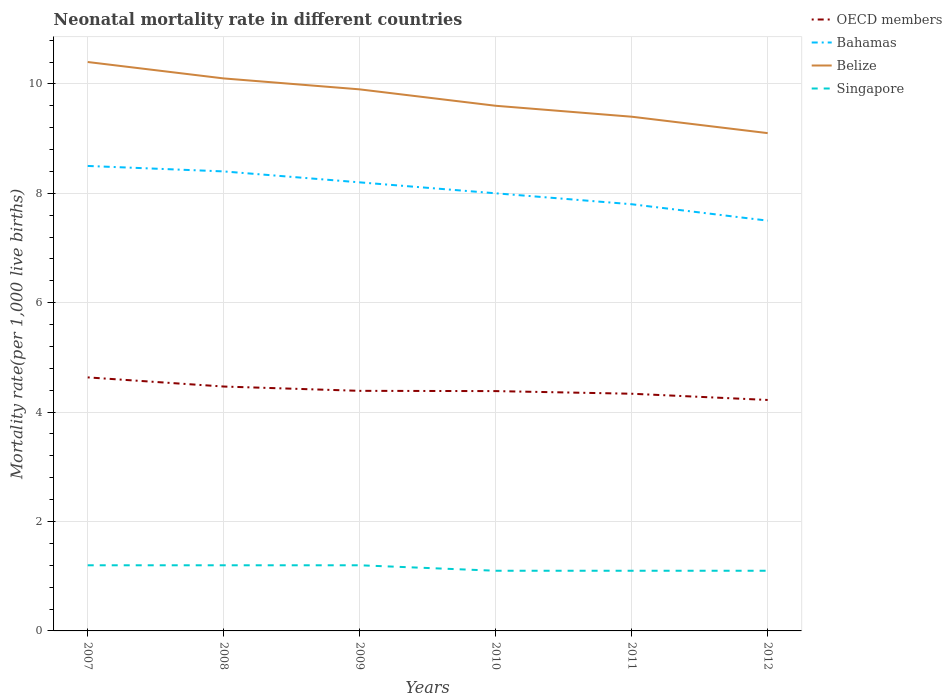How many different coloured lines are there?
Keep it short and to the point. 4. Does the line corresponding to Singapore intersect with the line corresponding to Bahamas?
Your answer should be very brief. No. In which year was the neonatal mortality rate in Singapore maximum?
Provide a succinct answer. 2010. What is the total neonatal mortality rate in Belize in the graph?
Your answer should be very brief. 1.3. What is the difference between the highest and the second highest neonatal mortality rate in Singapore?
Your response must be concise. 0.1. What is the difference between the highest and the lowest neonatal mortality rate in OECD members?
Give a very brief answer. 2. What is the difference between two consecutive major ticks on the Y-axis?
Provide a succinct answer. 2. Are the values on the major ticks of Y-axis written in scientific E-notation?
Provide a succinct answer. No. Does the graph contain grids?
Provide a succinct answer. Yes. How many legend labels are there?
Your answer should be compact. 4. What is the title of the graph?
Offer a very short reply. Neonatal mortality rate in different countries. What is the label or title of the Y-axis?
Ensure brevity in your answer.  Mortality rate(per 1,0 live births). What is the Mortality rate(per 1,000 live births) in OECD members in 2007?
Your answer should be very brief. 4.63. What is the Mortality rate(per 1,000 live births) of Belize in 2007?
Provide a succinct answer. 10.4. What is the Mortality rate(per 1,000 live births) in Singapore in 2007?
Keep it short and to the point. 1.2. What is the Mortality rate(per 1,000 live births) in OECD members in 2008?
Offer a very short reply. 4.47. What is the Mortality rate(per 1,000 live births) of Bahamas in 2008?
Your answer should be very brief. 8.4. What is the Mortality rate(per 1,000 live births) of Belize in 2008?
Your response must be concise. 10.1. What is the Mortality rate(per 1,000 live births) in Singapore in 2008?
Make the answer very short. 1.2. What is the Mortality rate(per 1,000 live births) of OECD members in 2009?
Your answer should be compact. 4.39. What is the Mortality rate(per 1,000 live births) of Bahamas in 2009?
Keep it short and to the point. 8.2. What is the Mortality rate(per 1,000 live births) in Singapore in 2009?
Offer a terse response. 1.2. What is the Mortality rate(per 1,000 live births) of OECD members in 2010?
Provide a succinct answer. 4.38. What is the Mortality rate(per 1,000 live births) in Belize in 2010?
Provide a succinct answer. 9.6. What is the Mortality rate(per 1,000 live births) of Singapore in 2010?
Provide a short and direct response. 1.1. What is the Mortality rate(per 1,000 live births) of OECD members in 2011?
Ensure brevity in your answer.  4.34. What is the Mortality rate(per 1,000 live births) of OECD members in 2012?
Keep it short and to the point. 4.22. What is the Mortality rate(per 1,000 live births) of Bahamas in 2012?
Make the answer very short. 7.5. What is the Mortality rate(per 1,000 live births) in Singapore in 2012?
Give a very brief answer. 1.1. Across all years, what is the maximum Mortality rate(per 1,000 live births) of OECD members?
Your response must be concise. 4.63. Across all years, what is the maximum Mortality rate(per 1,000 live births) of Belize?
Ensure brevity in your answer.  10.4. Across all years, what is the minimum Mortality rate(per 1,000 live births) of OECD members?
Give a very brief answer. 4.22. Across all years, what is the minimum Mortality rate(per 1,000 live births) of Singapore?
Give a very brief answer. 1.1. What is the total Mortality rate(per 1,000 live births) in OECD members in the graph?
Keep it short and to the point. 26.43. What is the total Mortality rate(per 1,000 live births) in Bahamas in the graph?
Provide a short and direct response. 48.4. What is the total Mortality rate(per 1,000 live births) in Belize in the graph?
Make the answer very short. 58.5. What is the difference between the Mortality rate(per 1,000 live births) in OECD members in 2007 and that in 2008?
Keep it short and to the point. 0.17. What is the difference between the Mortality rate(per 1,000 live births) in Bahamas in 2007 and that in 2008?
Your response must be concise. 0.1. What is the difference between the Mortality rate(per 1,000 live births) of OECD members in 2007 and that in 2009?
Offer a very short reply. 0.25. What is the difference between the Mortality rate(per 1,000 live births) of Bahamas in 2007 and that in 2009?
Keep it short and to the point. 0.3. What is the difference between the Mortality rate(per 1,000 live births) of Singapore in 2007 and that in 2009?
Offer a terse response. 0. What is the difference between the Mortality rate(per 1,000 live births) in OECD members in 2007 and that in 2010?
Provide a short and direct response. 0.25. What is the difference between the Mortality rate(per 1,000 live births) in Belize in 2007 and that in 2010?
Provide a succinct answer. 0.8. What is the difference between the Mortality rate(per 1,000 live births) in Singapore in 2007 and that in 2010?
Offer a very short reply. 0.1. What is the difference between the Mortality rate(per 1,000 live births) of OECD members in 2007 and that in 2011?
Your answer should be compact. 0.3. What is the difference between the Mortality rate(per 1,000 live births) in OECD members in 2007 and that in 2012?
Ensure brevity in your answer.  0.41. What is the difference between the Mortality rate(per 1,000 live births) of Bahamas in 2007 and that in 2012?
Offer a terse response. 1. What is the difference between the Mortality rate(per 1,000 live births) of OECD members in 2008 and that in 2009?
Give a very brief answer. 0.08. What is the difference between the Mortality rate(per 1,000 live births) in Belize in 2008 and that in 2009?
Offer a very short reply. 0.2. What is the difference between the Mortality rate(per 1,000 live births) of Singapore in 2008 and that in 2009?
Keep it short and to the point. 0. What is the difference between the Mortality rate(per 1,000 live births) in OECD members in 2008 and that in 2010?
Offer a very short reply. 0.08. What is the difference between the Mortality rate(per 1,000 live births) of Belize in 2008 and that in 2010?
Your answer should be very brief. 0.5. What is the difference between the Mortality rate(per 1,000 live births) of Singapore in 2008 and that in 2010?
Provide a succinct answer. 0.1. What is the difference between the Mortality rate(per 1,000 live births) in OECD members in 2008 and that in 2011?
Provide a succinct answer. 0.13. What is the difference between the Mortality rate(per 1,000 live births) of Singapore in 2008 and that in 2011?
Offer a very short reply. 0.1. What is the difference between the Mortality rate(per 1,000 live births) in OECD members in 2008 and that in 2012?
Your answer should be very brief. 0.25. What is the difference between the Mortality rate(per 1,000 live births) of OECD members in 2009 and that in 2010?
Make the answer very short. 0. What is the difference between the Mortality rate(per 1,000 live births) of OECD members in 2009 and that in 2011?
Offer a terse response. 0.05. What is the difference between the Mortality rate(per 1,000 live births) of Bahamas in 2009 and that in 2011?
Offer a terse response. 0.4. What is the difference between the Mortality rate(per 1,000 live births) of Belize in 2009 and that in 2011?
Your answer should be very brief. 0.5. What is the difference between the Mortality rate(per 1,000 live births) in OECD members in 2009 and that in 2012?
Make the answer very short. 0.17. What is the difference between the Mortality rate(per 1,000 live births) in Singapore in 2009 and that in 2012?
Provide a succinct answer. 0.1. What is the difference between the Mortality rate(per 1,000 live births) in OECD members in 2010 and that in 2011?
Ensure brevity in your answer.  0.05. What is the difference between the Mortality rate(per 1,000 live births) in Bahamas in 2010 and that in 2011?
Your answer should be compact. 0.2. What is the difference between the Mortality rate(per 1,000 live births) in Belize in 2010 and that in 2011?
Provide a succinct answer. 0.2. What is the difference between the Mortality rate(per 1,000 live births) of OECD members in 2010 and that in 2012?
Give a very brief answer. 0.16. What is the difference between the Mortality rate(per 1,000 live births) of OECD members in 2011 and that in 2012?
Make the answer very short. 0.11. What is the difference between the Mortality rate(per 1,000 live births) in Belize in 2011 and that in 2012?
Your response must be concise. 0.3. What is the difference between the Mortality rate(per 1,000 live births) in OECD members in 2007 and the Mortality rate(per 1,000 live births) in Bahamas in 2008?
Make the answer very short. -3.77. What is the difference between the Mortality rate(per 1,000 live births) of OECD members in 2007 and the Mortality rate(per 1,000 live births) of Belize in 2008?
Give a very brief answer. -5.47. What is the difference between the Mortality rate(per 1,000 live births) in OECD members in 2007 and the Mortality rate(per 1,000 live births) in Singapore in 2008?
Provide a succinct answer. 3.43. What is the difference between the Mortality rate(per 1,000 live births) of Belize in 2007 and the Mortality rate(per 1,000 live births) of Singapore in 2008?
Your answer should be compact. 9.2. What is the difference between the Mortality rate(per 1,000 live births) of OECD members in 2007 and the Mortality rate(per 1,000 live births) of Bahamas in 2009?
Provide a short and direct response. -3.57. What is the difference between the Mortality rate(per 1,000 live births) in OECD members in 2007 and the Mortality rate(per 1,000 live births) in Belize in 2009?
Give a very brief answer. -5.27. What is the difference between the Mortality rate(per 1,000 live births) in OECD members in 2007 and the Mortality rate(per 1,000 live births) in Singapore in 2009?
Give a very brief answer. 3.43. What is the difference between the Mortality rate(per 1,000 live births) of OECD members in 2007 and the Mortality rate(per 1,000 live births) of Bahamas in 2010?
Your response must be concise. -3.37. What is the difference between the Mortality rate(per 1,000 live births) in OECD members in 2007 and the Mortality rate(per 1,000 live births) in Belize in 2010?
Your answer should be very brief. -4.97. What is the difference between the Mortality rate(per 1,000 live births) of OECD members in 2007 and the Mortality rate(per 1,000 live births) of Singapore in 2010?
Ensure brevity in your answer.  3.53. What is the difference between the Mortality rate(per 1,000 live births) in Bahamas in 2007 and the Mortality rate(per 1,000 live births) in Belize in 2010?
Make the answer very short. -1.1. What is the difference between the Mortality rate(per 1,000 live births) in Belize in 2007 and the Mortality rate(per 1,000 live births) in Singapore in 2010?
Offer a very short reply. 9.3. What is the difference between the Mortality rate(per 1,000 live births) of OECD members in 2007 and the Mortality rate(per 1,000 live births) of Bahamas in 2011?
Your answer should be very brief. -3.17. What is the difference between the Mortality rate(per 1,000 live births) of OECD members in 2007 and the Mortality rate(per 1,000 live births) of Belize in 2011?
Give a very brief answer. -4.77. What is the difference between the Mortality rate(per 1,000 live births) in OECD members in 2007 and the Mortality rate(per 1,000 live births) in Singapore in 2011?
Ensure brevity in your answer.  3.53. What is the difference between the Mortality rate(per 1,000 live births) of OECD members in 2007 and the Mortality rate(per 1,000 live births) of Bahamas in 2012?
Give a very brief answer. -2.87. What is the difference between the Mortality rate(per 1,000 live births) in OECD members in 2007 and the Mortality rate(per 1,000 live births) in Belize in 2012?
Offer a terse response. -4.47. What is the difference between the Mortality rate(per 1,000 live births) of OECD members in 2007 and the Mortality rate(per 1,000 live births) of Singapore in 2012?
Ensure brevity in your answer.  3.53. What is the difference between the Mortality rate(per 1,000 live births) of Bahamas in 2007 and the Mortality rate(per 1,000 live births) of Singapore in 2012?
Provide a succinct answer. 7.4. What is the difference between the Mortality rate(per 1,000 live births) in OECD members in 2008 and the Mortality rate(per 1,000 live births) in Bahamas in 2009?
Offer a very short reply. -3.73. What is the difference between the Mortality rate(per 1,000 live births) of OECD members in 2008 and the Mortality rate(per 1,000 live births) of Belize in 2009?
Make the answer very short. -5.43. What is the difference between the Mortality rate(per 1,000 live births) in OECD members in 2008 and the Mortality rate(per 1,000 live births) in Singapore in 2009?
Keep it short and to the point. 3.27. What is the difference between the Mortality rate(per 1,000 live births) in Bahamas in 2008 and the Mortality rate(per 1,000 live births) in Singapore in 2009?
Provide a succinct answer. 7.2. What is the difference between the Mortality rate(per 1,000 live births) of OECD members in 2008 and the Mortality rate(per 1,000 live births) of Bahamas in 2010?
Your response must be concise. -3.53. What is the difference between the Mortality rate(per 1,000 live births) in OECD members in 2008 and the Mortality rate(per 1,000 live births) in Belize in 2010?
Your answer should be very brief. -5.13. What is the difference between the Mortality rate(per 1,000 live births) of OECD members in 2008 and the Mortality rate(per 1,000 live births) of Singapore in 2010?
Give a very brief answer. 3.37. What is the difference between the Mortality rate(per 1,000 live births) of OECD members in 2008 and the Mortality rate(per 1,000 live births) of Bahamas in 2011?
Give a very brief answer. -3.33. What is the difference between the Mortality rate(per 1,000 live births) in OECD members in 2008 and the Mortality rate(per 1,000 live births) in Belize in 2011?
Offer a terse response. -4.93. What is the difference between the Mortality rate(per 1,000 live births) of OECD members in 2008 and the Mortality rate(per 1,000 live births) of Singapore in 2011?
Offer a very short reply. 3.37. What is the difference between the Mortality rate(per 1,000 live births) in Bahamas in 2008 and the Mortality rate(per 1,000 live births) in Belize in 2011?
Keep it short and to the point. -1. What is the difference between the Mortality rate(per 1,000 live births) of Bahamas in 2008 and the Mortality rate(per 1,000 live births) of Singapore in 2011?
Your answer should be very brief. 7.3. What is the difference between the Mortality rate(per 1,000 live births) in Belize in 2008 and the Mortality rate(per 1,000 live births) in Singapore in 2011?
Give a very brief answer. 9. What is the difference between the Mortality rate(per 1,000 live births) in OECD members in 2008 and the Mortality rate(per 1,000 live births) in Bahamas in 2012?
Give a very brief answer. -3.03. What is the difference between the Mortality rate(per 1,000 live births) in OECD members in 2008 and the Mortality rate(per 1,000 live births) in Belize in 2012?
Make the answer very short. -4.63. What is the difference between the Mortality rate(per 1,000 live births) in OECD members in 2008 and the Mortality rate(per 1,000 live births) in Singapore in 2012?
Give a very brief answer. 3.37. What is the difference between the Mortality rate(per 1,000 live births) in Bahamas in 2008 and the Mortality rate(per 1,000 live births) in Belize in 2012?
Make the answer very short. -0.7. What is the difference between the Mortality rate(per 1,000 live births) in Bahamas in 2008 and the Mortality rate(per 1,000 live births) in Singapore in 2012?
Your answer should be very brief. 7.3. What is the difference between the Mortality rate(per 1,000 live births) of Belize in 2008 and the Mortality rate(per 1,000 live births) of Singapore in 2012?
Ensure brevity in your answer.  9. What is the difference between the Mortality rate(per 1,000 live births) of OECD members in 2009 and the Mortality rate(per 1,000 live births) of Bahamas in 2010?
Ensure brevity in your answer.  -3.61. What is the difference between the Mortality rate(per 1,000 live births) of OECD members in 2009 and the Mortality rate(per 1,000 live births) of Belize in 2010?
Provide a short and direct response. -5.21. What is the difference between the Mortality rate(per 1,000 live births) in OECD members in 2009 and the Mortality rate(per 1,000 live births) in Singapore in 2010?
Keep it short and to the point. 3.29. What is the difference between the Mortality rate(per 1,000 live births) of Bahamas in 2009 and the Mortality rate(per 1,000 live births) of Belize in 2010?
Provide a short and direct response. -1.4. What is the difference between the Mortality rate(per 1,000 live births) in OECD members in 2009 and the Mortality rate(per 1,000 live births) in Bahamas in 2011?
Offer a very short reply. -3.41. What is the difference between the Mortality rate(per 1,000 live births) in OECD members in 2009 and the Mortality rate(per 1,000 live births) in Belize in 2011?
Your answer should be compact. -5.01. What is the difference between the Mortality rate(per 1,000 live births) in OECD members in 2009 and the Mortality rate(per 1,000 live births) in Singapore in 2011?
Offer a terse response. 3.29. What is the difference between the Mortality rate(per 1,000 live births) of Bahamas in 2009 and the Mortality rate(per 1,000 live births) of Belize in 2011?
Offer a terse response. -1.2. What is the difference between the Mortality rate(per 1,000 live births) in Bahamas in 2009 and the Mortality rate(per 1,000 live births) in Singapore in 2011?
Your answer should be very brief. 7.1. What is the difference between the Mortality rate(per 1,000 live births) of OECD members in 2009 and the Mortality rate(per 1,000 live births) of Bahamas in 2012?
Give a very brief answer. -3.11. What is the difference between the Mortality rate(per 1,000 live births) of OECD members in 2009 and the Mortality rate(per 1,000 live births) of Belize in 2012?
Offer a very short reply. -4.71. What is the difference between the Mortality rate(per 1,000 live births) of OECD members in 2009 and the Mortality rate(per 1,000 live births) of Singapore in 2012?
Offer a terse response. 3.29. What is the difference between the Mortality rate(per 1,000 live births) in Bahamas in 2009 and the Mortality rate(per 1,000 live births) in Belize in 2012?
Provide a succinct answer. -0.9. What is the difference between the Mortality rate(per 1,000 live births) of Belize in 2009 and the Mortality rate(per 1,000 live births) of Singapore in 2012?
Keep it short and to the point. 8.8. What is the difference between the Mortality rate(per 1,000 live births) of OECD members in 2010 and the Mortality rate(per 1,000 live births) of Bahamas in 2011?
Provide a succinct answer. -3.42. What is the difference between the Mortality rate(per 1,000 live births) of OECD members in 2010 and the Mortality rate(per 1,000 live births) of Belize in 2011?
Your response must be concise. -5.02. What is the difference between the Mortality rate(per 1,000 live births) of OECD members in 2010 and the Mortality rate(per 1,000 live births) of Singapore in 2011?
Your answer should be compact. 3.28. What is the difference between the Mortality rate(per 1,000 live births) in Bahamas in 2010 and the Mortality rate(per 1,000 live births) in Singapore in 2011?
Your answer should be very brief. 6.9. What is the difference between the Mortality rate(per 1,000 live births) of Belize in 2010 and the Mortality rate(per 1,000 live births) of Singapore in 2011?
Your answer should be compact. 8.5. What is the difference between the Mortality rate(per 1,000 live births) of OECD members in 2010 and the Mortality rate(per 1,000 live births) of Bahamas in 2012?
Provide a short and direct response. -3.12. What is the difference between the Mortality rate(per 1,000 live births) in OECD members in 2010 and the Mortality rate(per 1,000 live births) in Belize in 2012?
Your answer should be very brief. -4.72. What is the difference between the Mortality rate(per 1,000 live births) of OECD members in 2010 and the Mortality rate(per 1,000 live births) of Singapore in 2012?
Offer a terse response. 3.28. What is the difference between the Mortality rate(per 1,000 live births) of Bahamas in 2010 and the Mortality rate(per 1,000 live births) of Singapore in 2012?
Offer a very short reply. 6.9. What is the difference between the Mortality rate(per 1,000 live births) in OECD members in 2011 and the Mortality rate(per 1,000 live births) in Bahamas in 2012?
Keep it short and to the point. -3.16. What is the difference between the Mortality rate(per 1,000 live births) of OECD members in 2011 and the Mortality rate(per 1,000 live births) of Belize in 2012?
Your answer should be compact. -4.76. What is the difference between the Mortality rate(per 1,000 live births) in OECD members in 2011 and the Mortality rate(per 1,000 live births) in Singapore in 2012?
Give a very brief answer. 3.24. What is the difference between the Mortality rate(per 1,000 live births) of Bahamas in 2011 and the Mortality rate(per 1,000 live births) of Belize in 2012?
Offer a terse response. -1.3. What is the average Mortality rate(per 1,000 live births) of OECD members per year?
Give a very brief answer. 4.41. What is the average Mortality rate(per 1,000 live births) in Bahamas per year?
Your response must be concise. 8.07. What is the average Mortality rate(per 1,000 live births) of Belize per year?
Your answer should be very brief. 9.75. What is the average Mortality rate(per 1,000 live births) of Singapore per year?
Your answer should be very brief. 1.15. In the year 2007, what is the difference between the Mortality rate(per 1,000 live births) of OECD members and Mortality rate(per 1,000 live births) of Bahamas?
Your answer should be compact. -3.87. In the year 2007, what is the difference between the Mortality rate(per 1,000 live births) of OECD members and Mortality rate(per 1,000 live births) of Belize?
Your answer should be very brief. -5.77. In the year 2007, what is the difference between the Mortality rate(per 1,000 live births) of OECD members and Mortality rate(per 1,000 live births) of Singapore?
Your response must be concise. 3.43. In the year 2007, what is the difference between the Mortality rate(per 1,000 live births) in Bahamas and Mortality rate(per 1,000 live births) in Belize?
Provide a short and direct response. -1.9. In the year 2007, what is the difference between the Mortality rate(per 1,000 live births) in Bahamas and Mortality rate(per 1,000 live births) in Singapore?
Give a very brief answer. 7.3. In the year 2008, what is the difference between the Mortality rate(per 1,000 live births) of OECD members and Mortality rate(per 1,000 live births) of Bahamas?
Ensure brevity in your answer.  -3.93. In the year 2008, what is the difference between the Mortality rate(per 1,000 live births) of OECD members and Mortality rate(per 1,000 live births) of Belize?
Your answer should be compact. -5.63. In the year 2008, what is the difference between the Mortality rate(per 1,000 live births) of OECD members and Mortality rate(per 1,000 live births) of Singapore?
Your response must be concise. 3.27. In the year 2008, what is the difference between the Mortality rate(per 1,000 live births) in Bahamas and Mortality rate(per 1,000 live births) in Singapore?
Your answer should be compact. 7.2. In the year 2009, what is the difference between the Mortality rate(per 1,000 live births) of OECD members and Mortality rate(per 1,000 live births) of Bahamas?
Provide a succinct answer. -3.81. In the year 2009, what is the difference between the Mortality rate(per 1,000 live births) in OECD members and Mortality rate(per 1,000 live births) in Belize?
Make the answer very short. -5.51. In the year 2009, what is the difference between the Mortality rate(per 1,000 live births) in OECD members and Mortality rate(per 1,000 live births) in Singapore?
Give a very brief answer. 3.19. In the year 2009, what is the difference between the Mortality rate(per 1,000 live births) in Bahamas and Mortality rate(per 1,000 live births) in Singapore?
Make the answer very short. 7. In the year 2009, what is the difference between the Mortality rate(per 1,000 live births) of Belize and Mortality rate(per 1,000 live births) of Singapore?
Your answer should be compact. 8.7. In the year 2010, what is the difference between the Mortality rate(per 1,000 live births) in OECD members and Mortality rate(per 1,000 live births) in Bahamas?
Offer a very short reply. -3.62. In the year 2010, what is the difference between the Mortality rate(per 1,000 live births) in OECD members and Mortality rate(per 1,000 live births) in Belize?
Your answer should be very brief. -5.22. In the year 2010, what is the difference between the Mortality rate(per 1,000 live births) in OECD members and Mortality rate(per 1,000 live births) in Singapore?
Offer a very short reply. 3.28. In the year 2010, what is the difference between the Mortality rate(per 1,000 live births) in Bahamas and Mortality rate(per 1,000 live births) in Belize?
Give a very brief answer. -1.6. In the year 2010, what is the difference between the Mortality rate(per 1,000 live births) of Belize and Mortality rate(per 1,000 live births) of Singapore?
Your answer should be compact. 8.5. In the year 2011, what is the difference between the Mortality rate(per 1,000 live births) of OECD members and Mortality rate(per 1,000 live births) of Bahamas?
Provide a succinct answer. -3.46. In the year 2011, what is the difference between the Mortality rate(per 1,000 live births) of OECD members and Mortality rate(per 1,000 live births) of Belize?
Offer a terse response. -5.06. In the year 2011, what is the difference between the Mortality rate(per 1,000 live births) in OECD members and Mortality rate(per 1,000 live births) in Singapore?
Provide a short and direct response. 3.24. In the year 2011, what is the difference between the Mortality rate(per 1,000 live births) of Bahamas and Mortality rate(per 1,000 live births) of Belize?
Provide a succinct answer. -1.6. In the year 2011, what is the difference between the Mortality rate(per 1,000 live births) in Belize and Mortality rate(per 1,000 live births) in Singapore?
Offer a very short reply. 8.3. In the year 2012, what is the difference between the Mortality rate(per 1,000 live births) in OECD members and Mortality rate(per 1,000 live births) in Bahamas?
Your response must be concise. -3.28. In the year 2012, what is the difference between the Mortality rate(per 1,000 live births) in OECD members and Mortality rate(per 1,000 live births) in Belize?
Your response must be concise. -4.88. In the year 2012, what is the difference between the Mortality rate(per 1,000 live births) of OECD members and Mortality rate(per 1,000 live births) of Singapore?
Your response must be concise. 3.12. In the year 2012, what is the difference between the Mortality rate(per 1,000 live births) in Bahamas and Mortality rate(per 1,000 live births) in Singapore?
Provide a short and direct response. 6.4. What is the ratio of the Mortality rate(per 1,000 live births) of OECD members in 2007 to that in 2008?
Give a very brief answer. 1.04. What is the ratio of the Mortality rate(per 1,000 live births) of Bahamas in 2007 to that in 2008?
Your answer should be compact. 1.01. What is the ratio of the Mortality rate(per 1,000 live births) of Belize in 2007 to that in 2008?
Make the answer very short. 1.03. What is the ratio of the Mortality rate(per 1,000 live births) of OECD members in 2007 to that in 2009?
Give a very brief answer. 1.06. What is the ratio of the Mortality rate(per 1,000 live births) in Bahamas in 2007 to that in 2009?
Your answer should be very brief. 1.04. What is the ratio of the Mortality rate(per 1,000 live births) in Belize in 2007 to that in 2009?
Your response must be concise. 1.05. What is the ratio of the Mortality rate(per 1,000 live births) of OECD members in 2007 to that in 2010?
Your answer should be very brief. 1.06. What is the ratio of the Mortality rate(per 1,000 live births) in Singapore in 2007 to that in 2010?
Offer a terse response. 1.09. What is the ratio of the Mortality rate(per 1,000 live births) in OECD members in 2007 to that in 2011?
Keep it short and to the point. 1.07. What is the ratio of the Mortality rate(per 1,000 live births) of Bahamas in 2007 to that in 2011?
Provide a succinct answer. 1.09. What is the ratio of the Mortality rate(per 1,000 live births) in Belize in 2007 to that in 2011?
Offer a very short reply. 1.11. What is the ratio of the Mortality rate(per 1,000 live births) of Singapore in 2007 to that in 2011?
Your answer should be very brief. 1.09. What is the ratio of the Mortality rate(per 1,000 live births) of OECD members in 2007 to that in 2012?
Your answer should be very brief. 1.1. What is the ratio of the Mortality rate(per 1,000 live births) in Bahamas in 2007 to that in 2012?
Provide a short and direct response. 1.13. What is the ratio of the Mortality rate(per 1,000 live births) of Belize in 2007 to that in 2012?
Your answer should be compact. 1.14. What is the ratio of the Mortality rate(per 1,000 live births) of OECD members in 2008 to that in 2009?
Your answer should be compact. 1.02. What is the ratio of the Mortality rate(per 1,000 live births) of Bahamas in 2008 to that in 2009?
Give a very brief answer. 1.02. What is the ratio of the Mortality rate(per 1,000 live births) of Belize in 2008 to that in 2009?
Keep it short and to the point. 1.02. What is the ratio of the Mortality rate(per 1,000 live births) in Bahamas in 2008 to that in 2010?
Provide a succinct answer. 1.05. What is the ratio of the Mortality rate(per 1,000 live births) in Belize in 2008 to that in 2010?
Your answer should be compact. 1.05. What is the ratio of the Mortality rate(per 1,000 live births) of OECD members in 2008 to that in 2011?
Provide a short and direct response. 1.03. What is the ratio of the Mortality rate(per 1,000 live births) of Belize in 2008 to that in 2011?
Offer a terse response. 1.07. What is the ratio of the Mortality rate(per 1,000 live births) in Singapore in 2008 to that in 2011?
Your response must be concise. 1.09. What is the ratio of the Mortality rate(per 1,000 live births) of OECD members in 2008 to that in 2012?
Offer a very short reply. 1.06. What is the ratio of the Mortality rate(per 1,000 live births) in Bahamas in 2008 to that in 2012?
Ensure brevity in your answer.  1.12. What is the ratio of the Mortality rate(per 1,000 live births) of Belize in 2008 to that in 2012?
Keep it short and to the point. 1.11. What is the ratio of the Mortality rate(per 1,000 live births) in Bahamas in 2009 to that in 2010?
Offer a terse response. 1.02. What is the ratio of the Mortality rate(per 1,000 live births) in Belize in 2009 to that in 2010?
Offer a very short reply. 1.03. What is the ratio of the Mortality rate(per 1,000 live births) in OECD members in 2009 to that in 2011?
Your answer should be compact. 1.01. What is the ratio of the Mortality rate(per 1,000 live births) of Bahamas in 2009 to that in 2011?
Offer a very short reply. 1.05. What is the ratio of the Mortality rate(per 1,000 live births) in Belize in 2009 to that in 2011?
Give a very brief answer. 1.05. What is the ratio of the Mortality rate(per 1,000 live births) in Singapore in 2009 to that in 2011?
Keep it short and to the point. 1.09. What is the ratio of the Mortality rate(per 1,000 live births) of OECD members in 2009 to that in 2012?
Your answer should be compact. 1.04. What is the ratio of the Mortality rate(per 1,000 live births) in Bahamas in 2009 to that in 2012?
Ensure brevity in your answer.  1.09. What is the ratio of the Mortality rate(per 1,000 live births) of Belize in 2009 to that in 2012?
Your answer should be very brief. 1.09. What is the ratio of the Mortality rate(per 1,000 live births) in Singapore in 2009 to that in 2012?
Your answer should be very brief. 1.09. What is the ratio of the Mortality rate(per 1,000 live births) of OECD members in 2010 to that in 2011?
Ensure brevity in your answer.  1.01. What is the ratio of the Mortality rate(per 1,000 live births) in Bahamas in 2010 to that in 2011?
Your response must be concise. 1.03. What is the ratio of the Mortality rate(per 1,000 live births) in Belize in 2010 to that in 2011?
Make the answer very short. 1.02. What is the ratio of the Mortality rate(per 1,000 live births) in OECD members in 2010 to that in 2012?
Provide a short and direct response. 1.04. What is the ratio of the Mortality rate(per 1,000 live births) of Bahamas in 2010 to that in 2012?
Your answer should be very brief. 1.07. What is the ratio of the Mortality rate(per 1,000 live births) in Belize in 2010 to that in 2012?
Give a very brief answer. 1.05. What is the ratio of the Mortality rate(per 1,000 live births) of OECD members in 2011 to that in 2012?
Offer a terse response. 1.03. What is the ratio of the Mortality rate(per 1,000 live births) of Belize in 2011 to that in 2012?
Offer a terse response. 1.03. What is the ratio of the Mortality rate(per 1,000 live births) of Singapore in 2011 to that in 2012?
Offer a terse response. 1. What is the difference between the highest and the second highest Mortality rate(per 1,000 live births) in OECD members?
Make the answer very short. 0.17. What is the difference between the highest and the second highest Mortality rate(per 1,000 live births) of Bahamas?
Your response must be concise. 0.1. What is the difference between the highest and the second highest Mortality rate(per 1,000 live births) of Belize?
Offer a terse response. 0.3. What is the difference between the highest and the lowest Mortality rate(per 1,000 live births) of OECD members?
Keep it short and to the point. 0.41. 